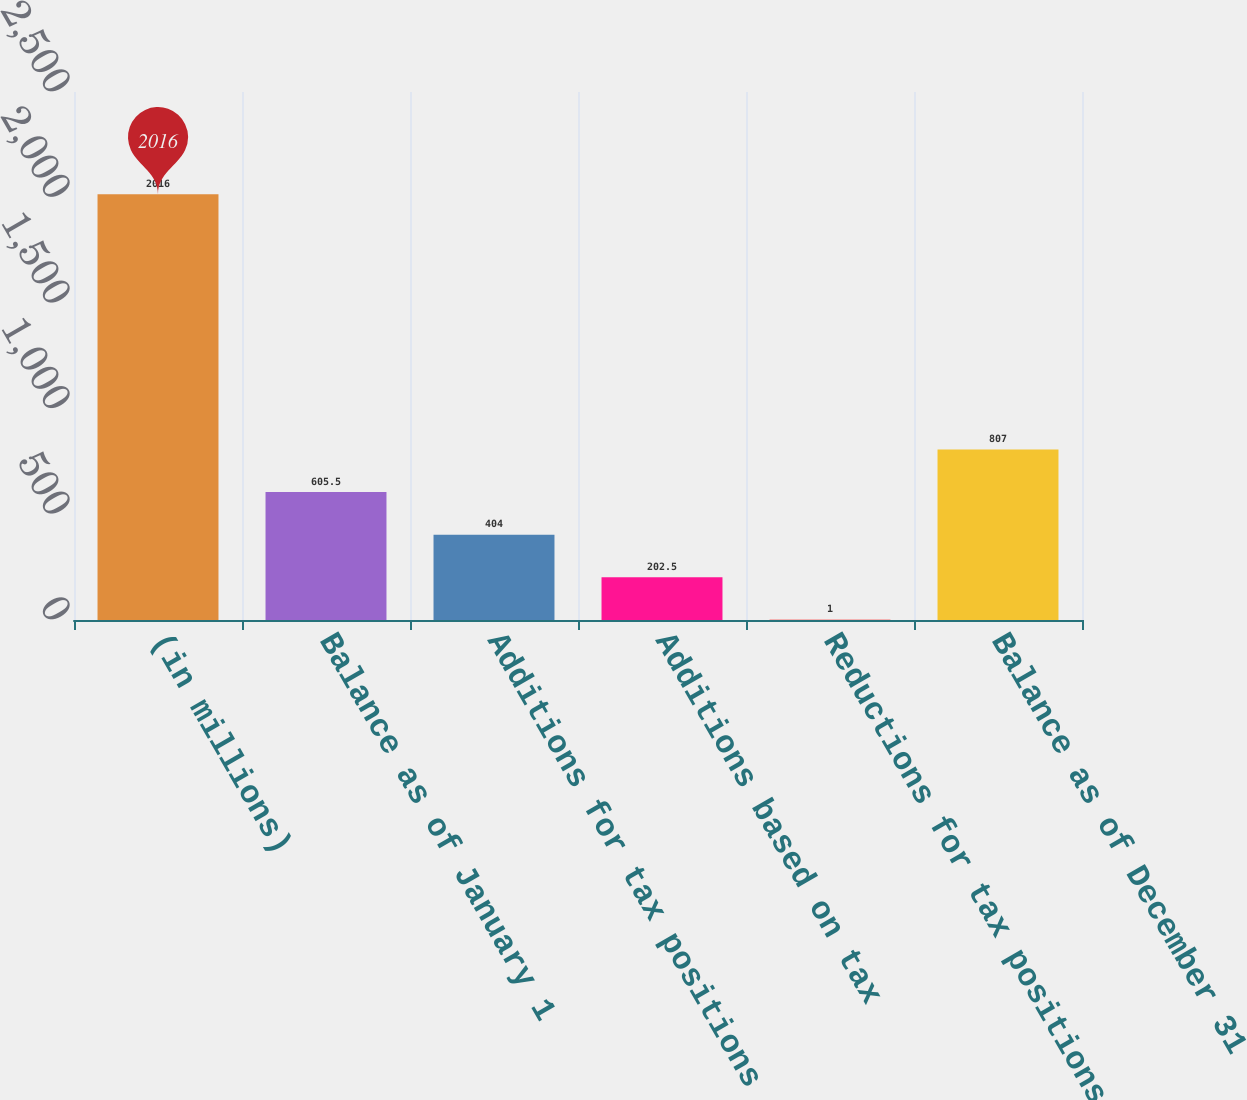Convert chart to OTSL. <chart><loc_0><loc_0><loc_500><loc_500><bar_chart><fcel>(in millions)<fcel>Balance as of January 1<fcel>Additions for tax positions of<fcel>Additions based on tax<fcel>Reductions for tax positions<fcel>Balance as of December 31<nl><fcel>2016<fcel>605.5<fcel>404<fcel>202.5<fcel>1<fcel>807<nl></chart> 